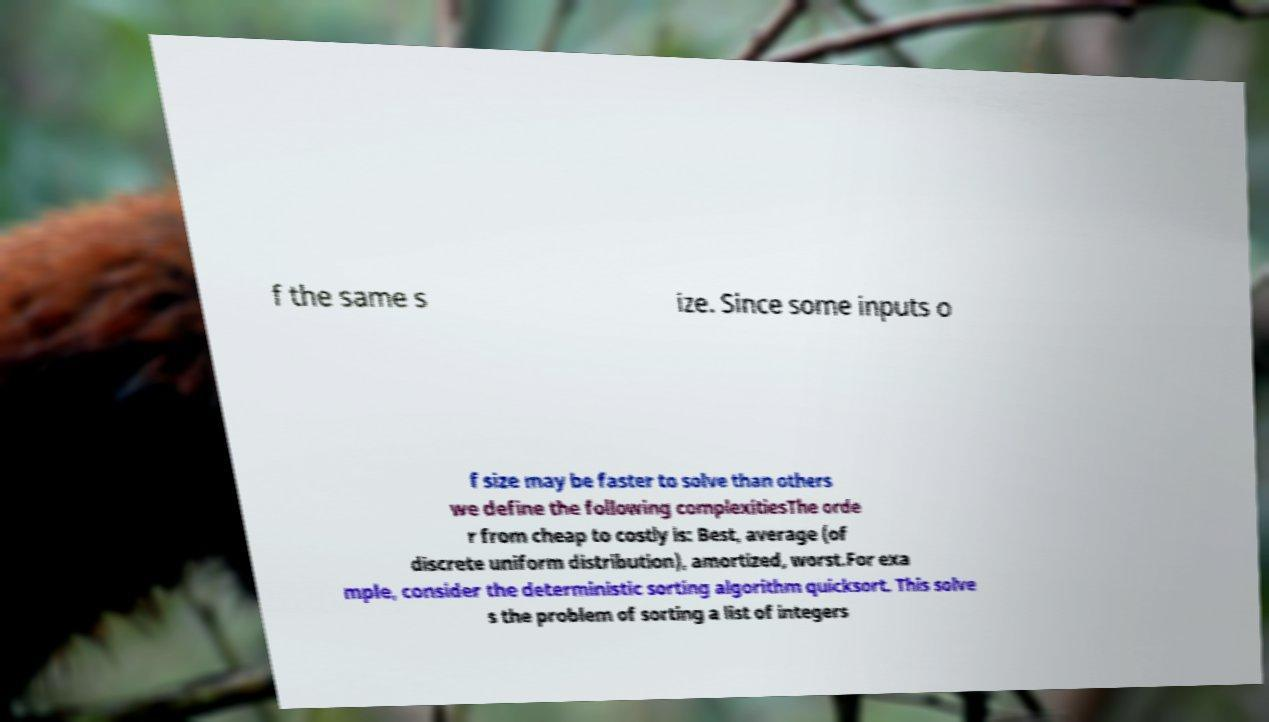Can you accurately transcribe the text from the provided image for me? f the same s ize. Since some inputs o f size may be faster to solve than others we define the following complexitiesThe orde r from cheap to costly is: Best, average (of discrete uniform distribution), amortized, worst.For exa mple, consider the deterministic sorting algorithm quicksort. This solve s the problem of sorting a list of integers 